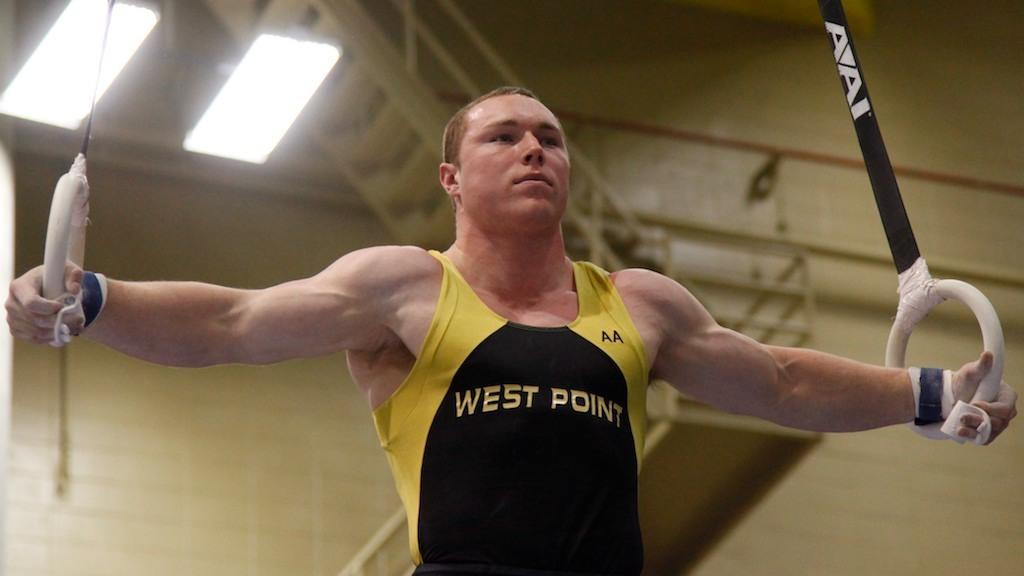<image>
Render a clear and concise summary of the photo. a man that has a west point outfit on while lifting weights 